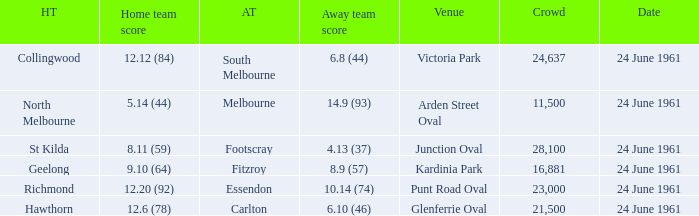What was the average crowd size of games held at Glenferrie Oval? 21500.0. 